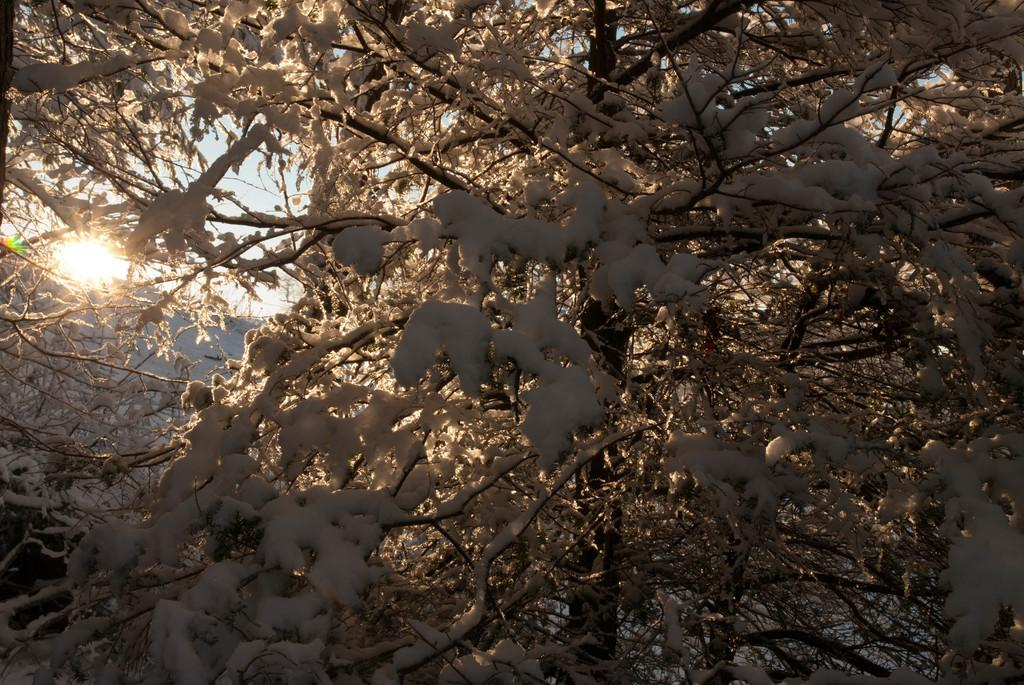What is located at the front of the image? There is a tree in the front of the image. What is covering the branches of the tree? Snow is present on the branches of the tree. What can be seen in the background of the image? The sky is visible in the background of the image. What type of zipper can be seen on the tree in the image? There is no zipper present on the tree in the image. 